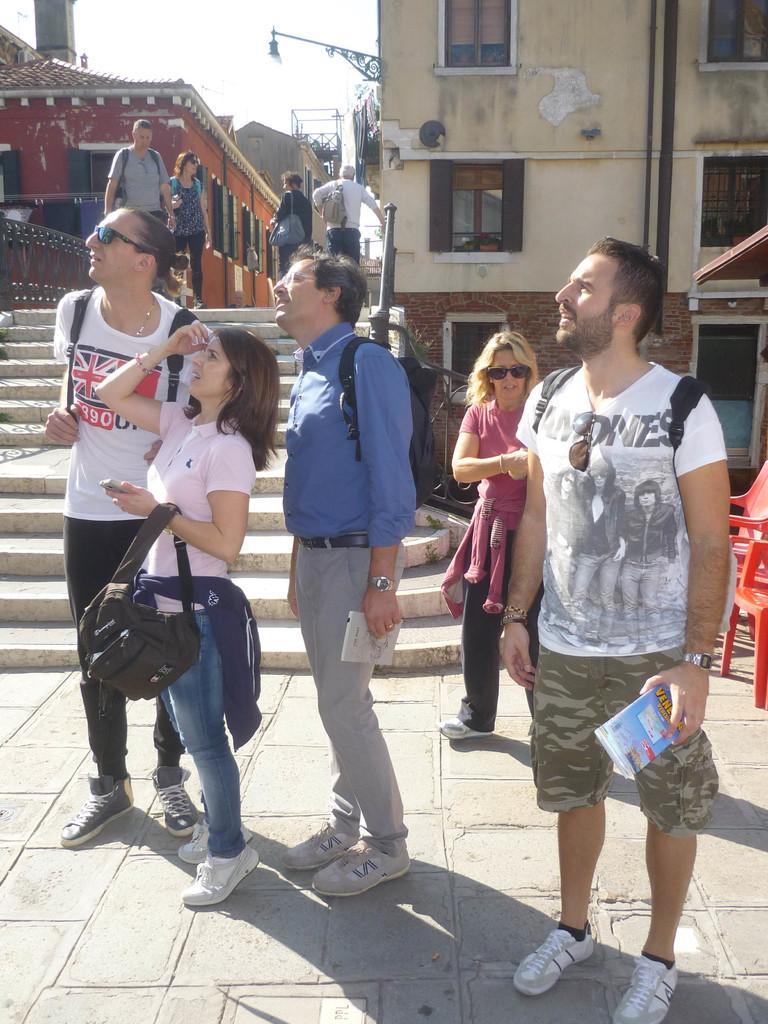Can you describe this image briefly? In this image I can see the group of people with different color dresses. These people are with the bags. To the right I can see the red color chairs. In the background I can see the few more people, buildings and the sky. 